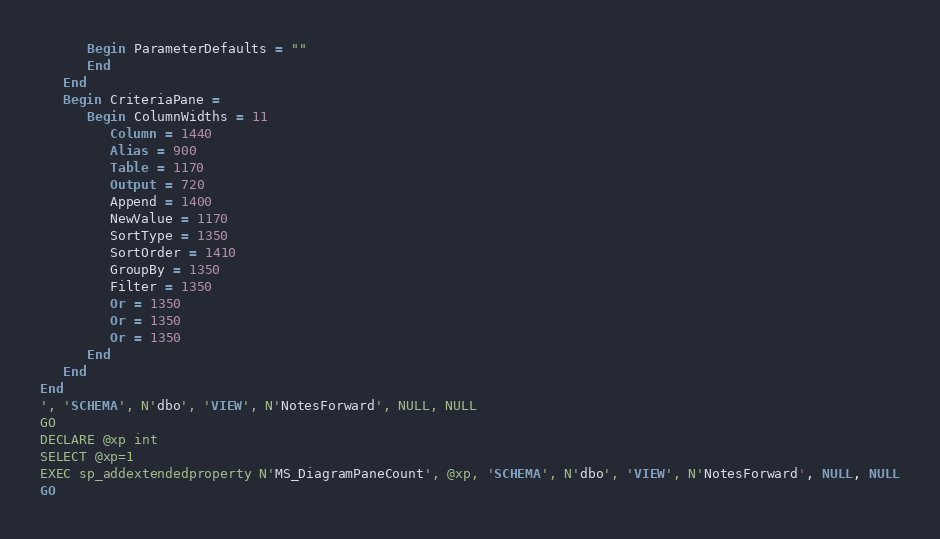<code> <loc_0><loc_0><loc_500><loc_500><_SQL_>      Begin ParameterDefaults = ""
      End
   End
   Begin CriteriaPane = 
      Begin ColumnWidths = 11
         Column = 1440
         Alias = 900
         Table = 1170
         Output = 720
         Append = 1400
         NewValue = 1170
         SortType = 1350
         SortOrder = 1410
         GroupBy = 1350
         Filter = 1350
         Or = 1350
         Or = 1350
         Or = 1350
      End
   End
End
', 'SCHEMA', N'dbo', 'VIEW', N'NotesForward', NULL, NULL
GO
DECLARE @xp int
SELECT @xp=1
EXEC sp_addextendedproperty N'MS_DiagramPaneCount', @xp, 'SCHEMA', N'dbo', 'VIEW', N'NotesForward', NULL, NULL
GO
</code> 